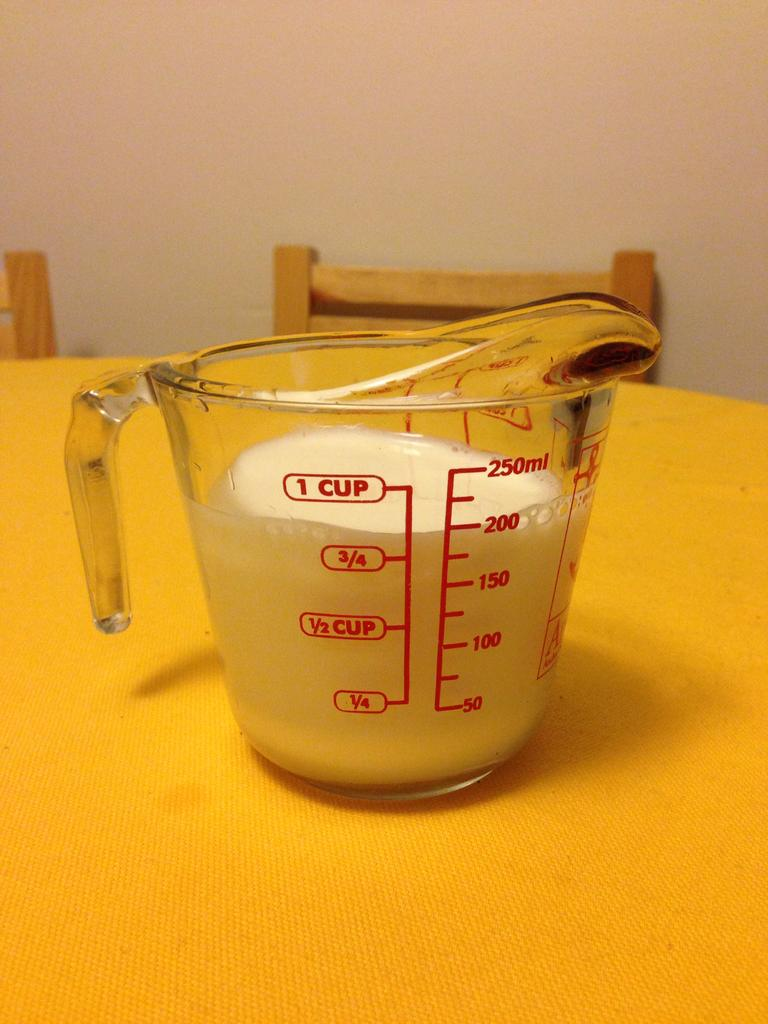<image>
Create a compact narrative representing the image presented. Just over 3/4 of a cup of milk is in a glass measuring cup on a round table. 